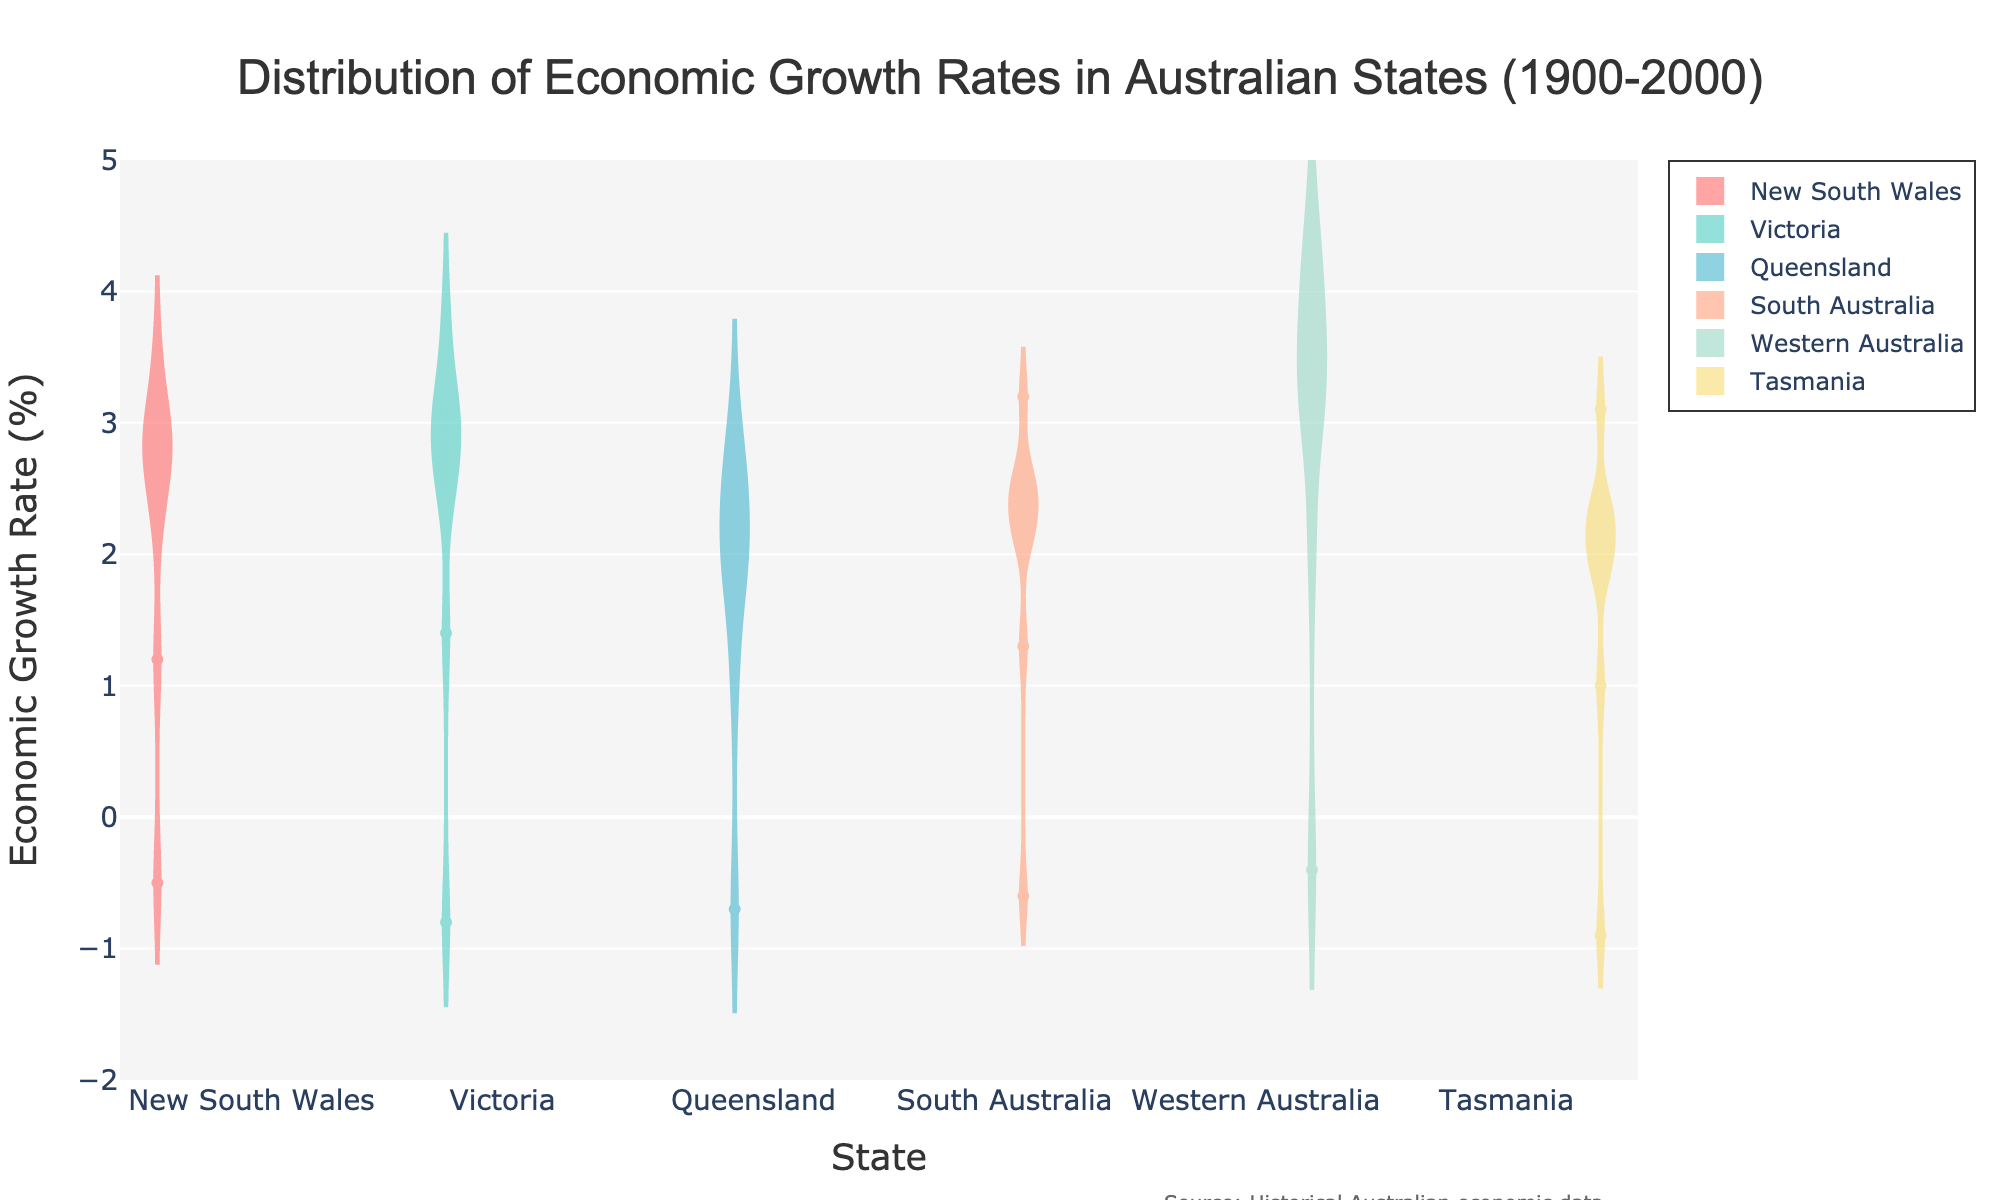What is the title of the density plot? The title is usually centered at the top of the figure. In this plot, it is clearly written at the top.
Answer: Distribution of Economic Growth Rates in Australian States (1900-2000) Which state has the widest spread in economic growth rates? By examining the width of the violins, you can see which state's data covers the broadest range along the y-axis. Western Australia shows the widest spread as it covers the range from almost -1% to above 4%.
Answer: Western Australia Which state has the highest peak in economic growth rates? The peak is indicated by the density distribution of the violins, showing where most data points are concentrated. Western Australia has a higher central tendency around 3%-4%.
Answer: Western Australia What is the median economic growth rate for Victoria? The median can be found by looking at the horizontal line inside the violin for Victoria. The line appears around 2.9%.
Answer: 2.9% Which state has a median economic growth lower than 2.5%? Compare the median lines across all violins. Both Queensland and Tasmania show median values below 2.5%.
Answer: Queensland and Tasmania How do the median growth rates of New South Wales and South Australia compare? Look at the horizontal median lines in the violins for both states. New South Wales has a median of around 2.7%, while South Australia has a median of 2.4%.
Answer: New South Wales has a higher median than South Australia What range of economic growth rates is common in Tasmania? To find the common range, look at the middle density of the violin. For Tasmania, it mainly ranges from about 1% to 3%.
Answer: 1% to 3% Which state experienced economic downturns (negative growth rates) according to the plot? The violins that extend to the negative values on the y-axis represent states with economic downturns. New South Wales, Victoria, Queensland, South Australia, and Tasmania have violins extending below 0%.
Answer: New South Wales, Victoria, Queensland, South Australia, and Tasmania What is the interquartile range (IQR) for Queensland's economic growth? The IQR is the range between the 25th percentile and the 75th percentile, which can be visually estimated by the height of the box in the violin. For Queensland, this visually appears from around 1.7% to 2.6%.
Answer: Approximately 1.7% to 2.6% 